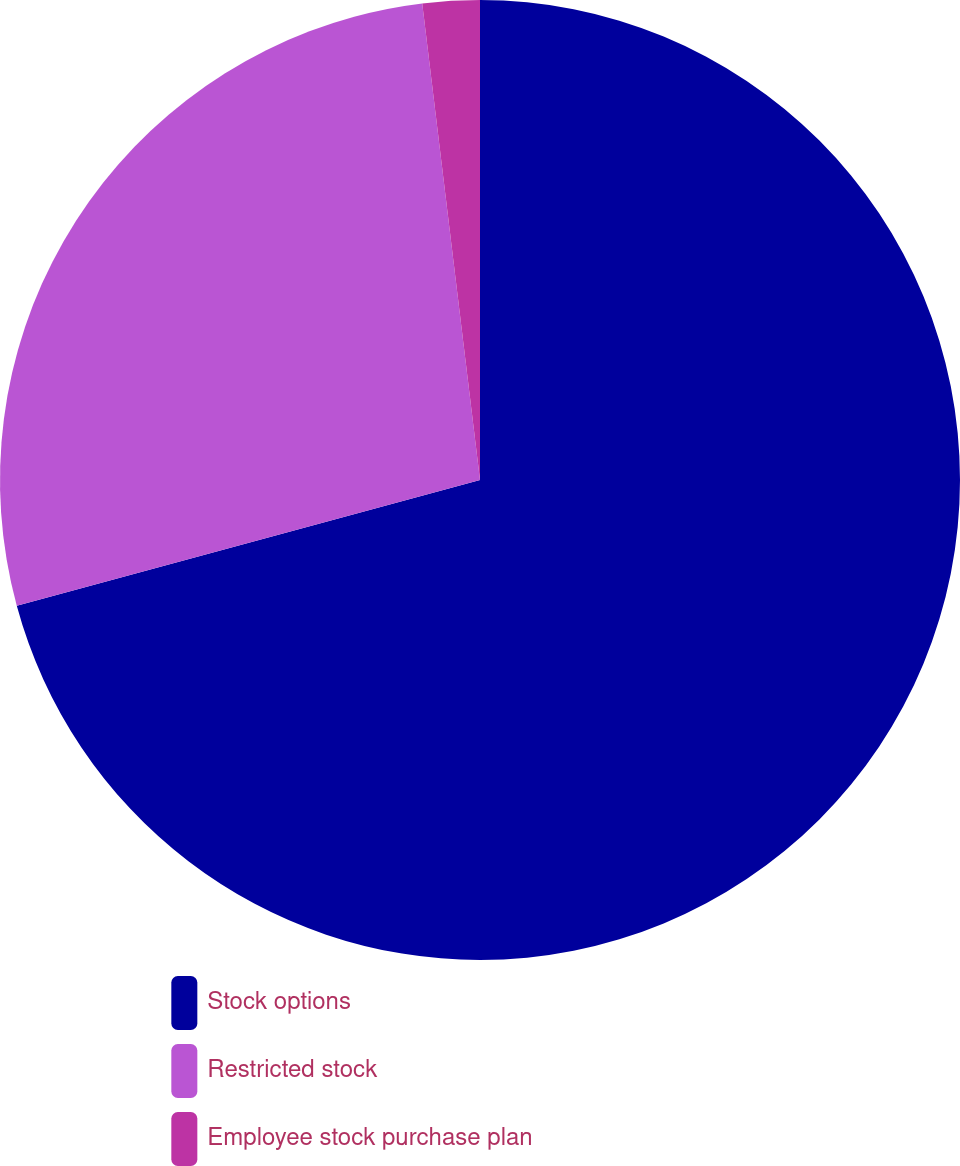Convert chart. <chart><loc_0><loc_0><loc_500><loc_500><pie_chart><fcel>Stock options<fcel>Restricted stock<fcel>Employee stock purchase plan<nl><fcel>70.78%<fcel>27.3%<fcel>1.92%<nl></chart> 